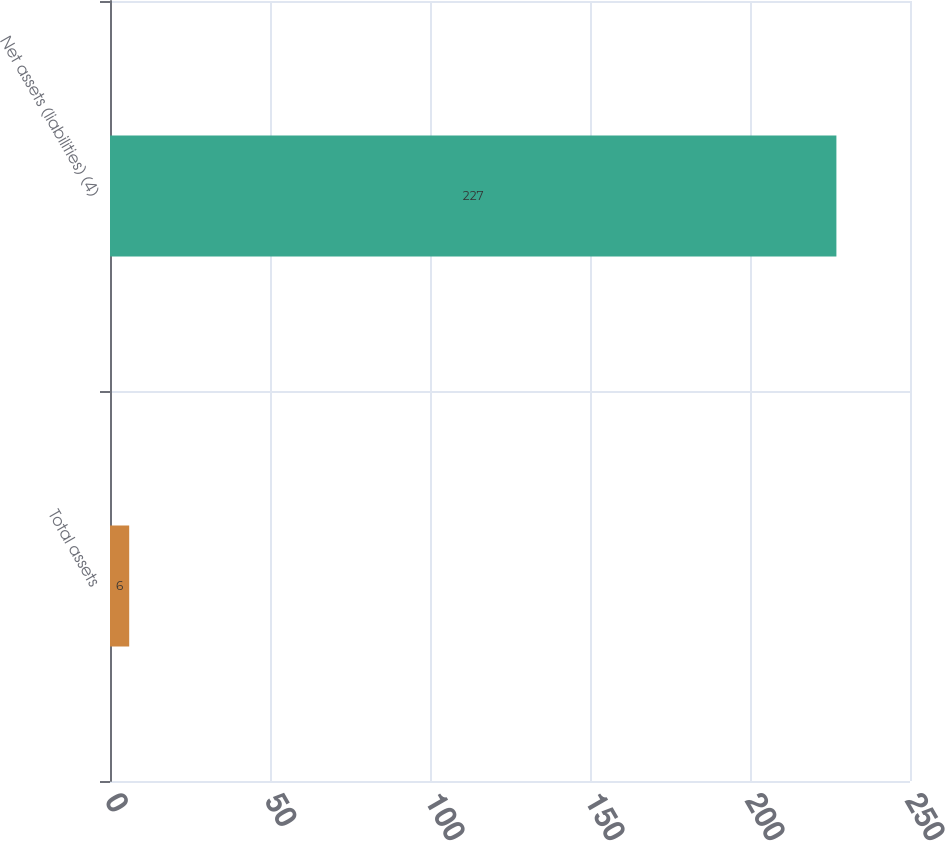Convert chart. <chart><loc_0><loc_0><loc_500><loc_500><bar_chart><fcel>Total assets<fcel>Net assets (liabilities) (4)<nl><fcel>6<fcel>227<nl></chart> 